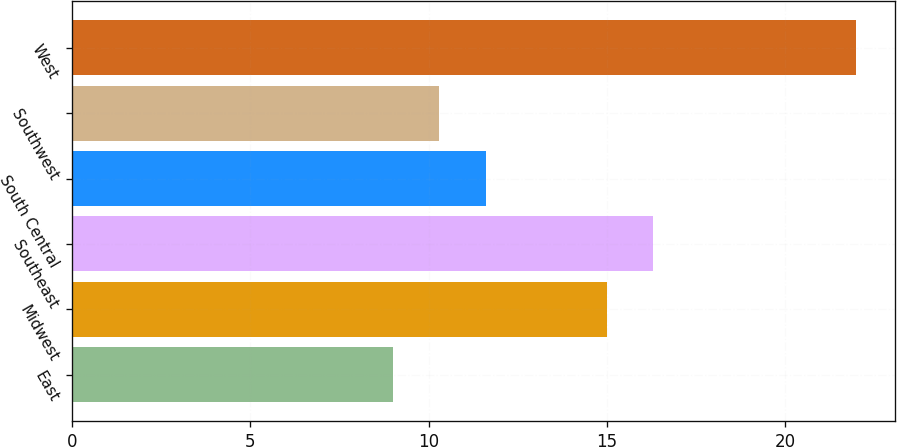Convert chart to OTSL. <chart><loc_0><loc_0><loc_500><loc_500><bar_chart><fcel>East<fcel>Midwest<fcel>Southeast<fcel>South Central<fcel>Southwest<fcel>West<nl><fcel>9<fcel>15<fcel>16.3<fcel>11.6<fcel>10.3<fcel>22<nl></chart> 